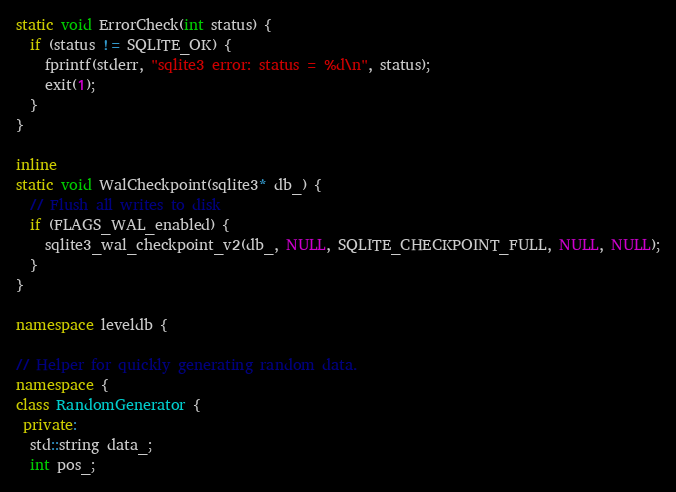<code> <loc_0><loc_0><loc_500><loc_500><_C++_>static void ErrorCheck(int status) {
  if (status != SQLITE_OK) {
    fprintf(stderr, "sqlite3 error: status = %d\n", status);
    exit(1);
  }
}

inline
static void WalCheckpoint(sqlite3* db_) {
  // Flush all writes to disk
  if (FLAGS_WAL_enabled) {
    sqlite3_wal_checkpoint_v2(db_, NULL, SQLITE_CHECKPOINT_FULL, NULL, NULL);
  }
}

namespace leveldb {

// Helper for quickly generating random data.
namespace {
class RandomGenerator {
 private:
  std::string data_;
  int pos_;
</code> 